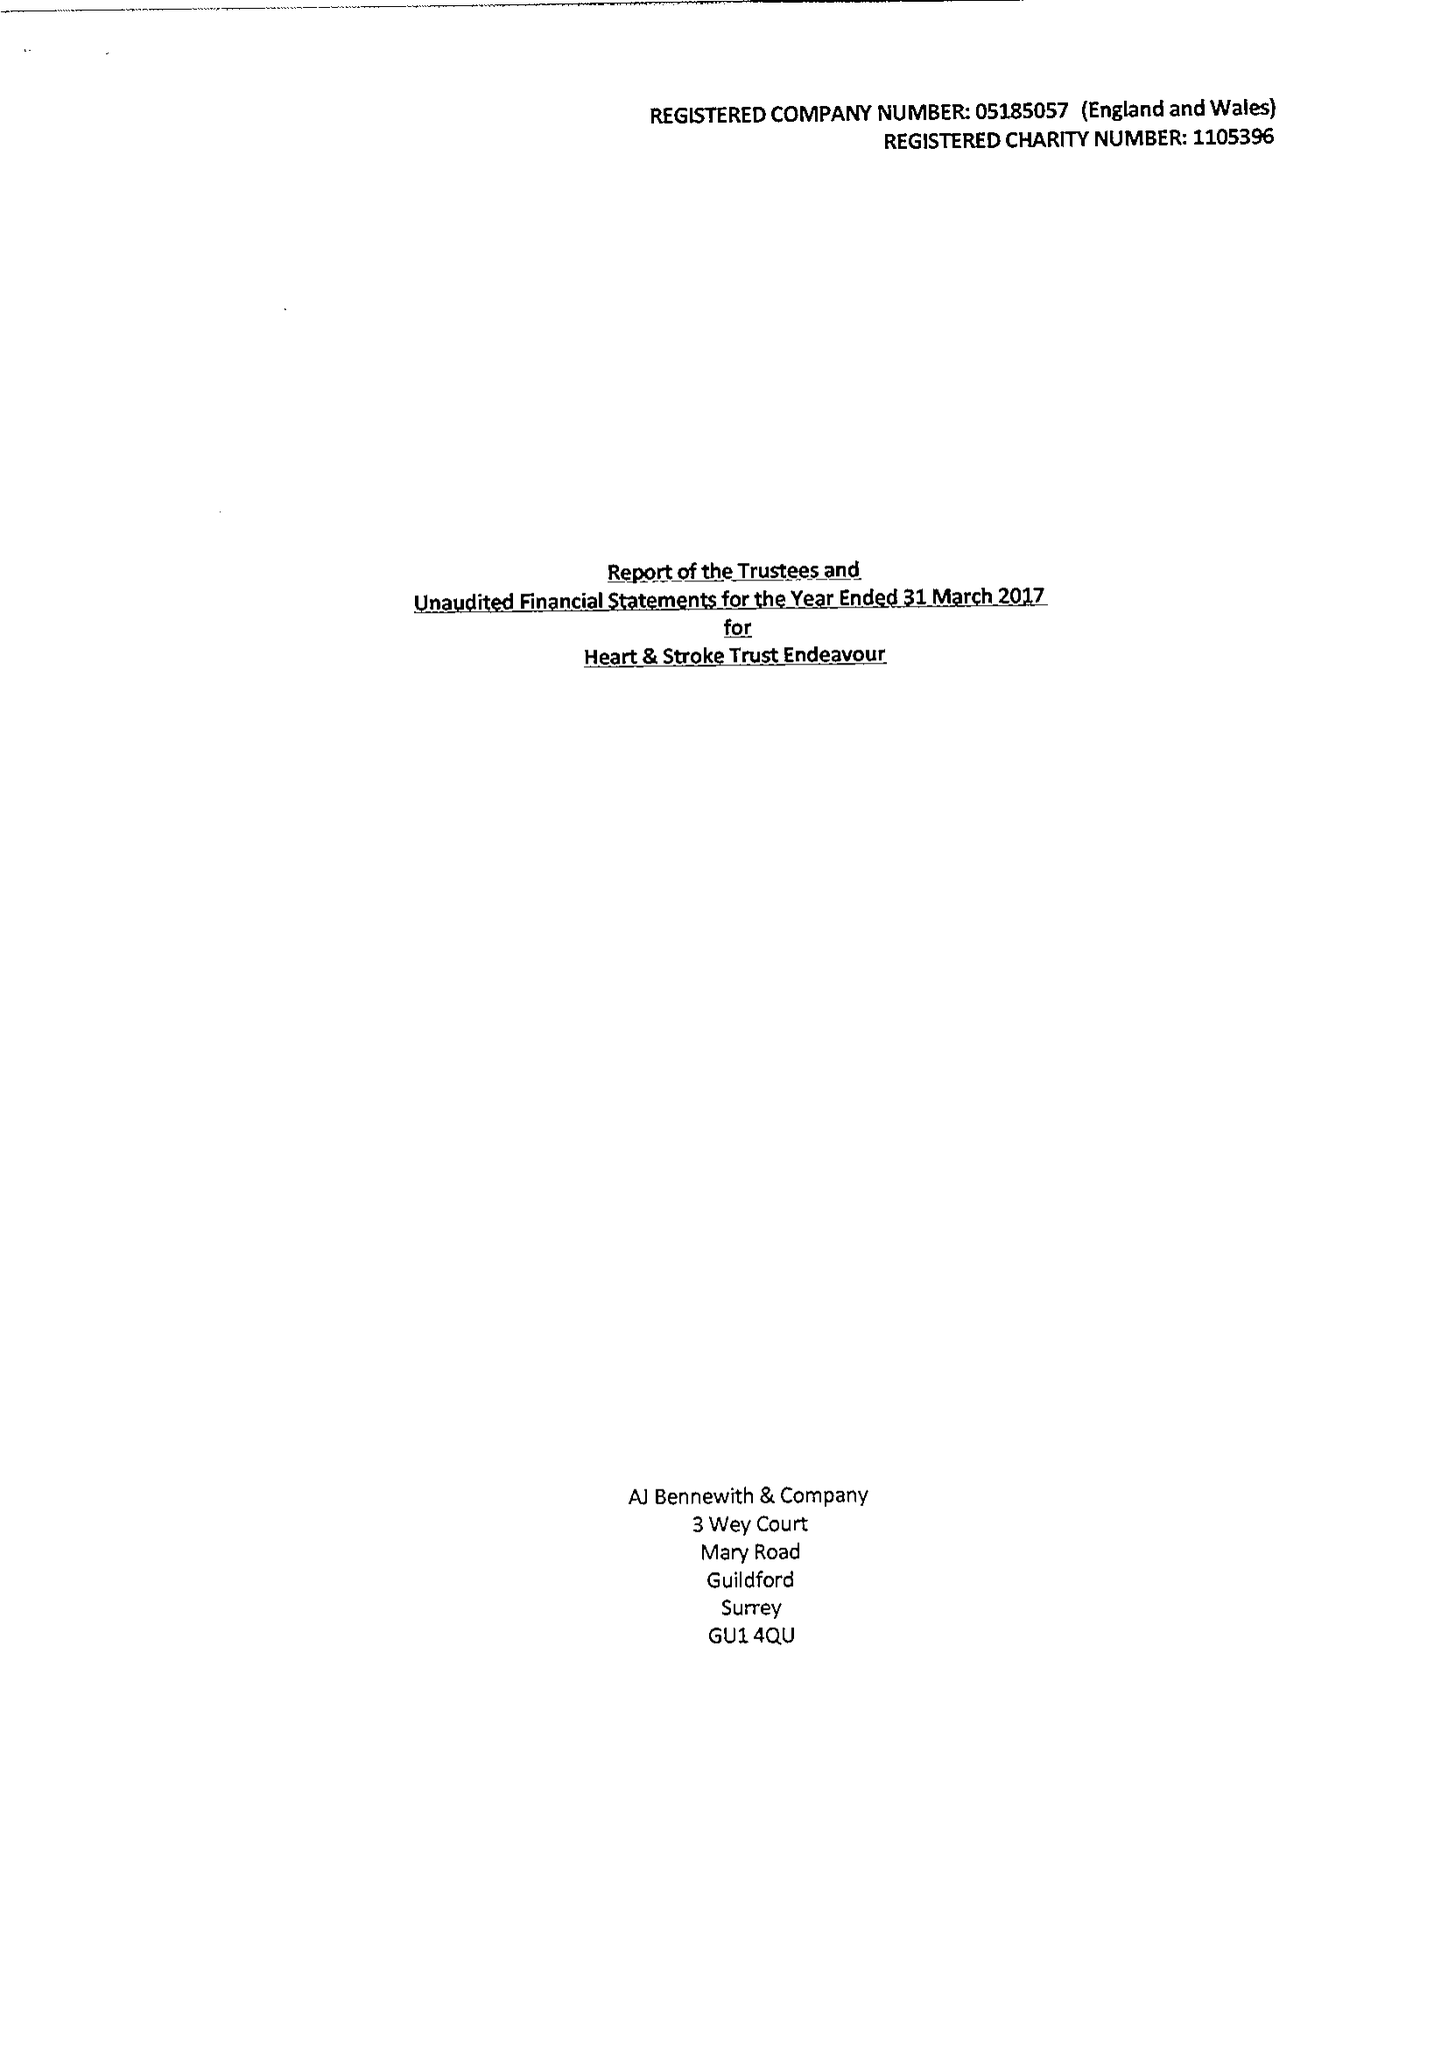What is the value for the address__postcode?
Answer the question using a single word or phrase. GU2 7YD 